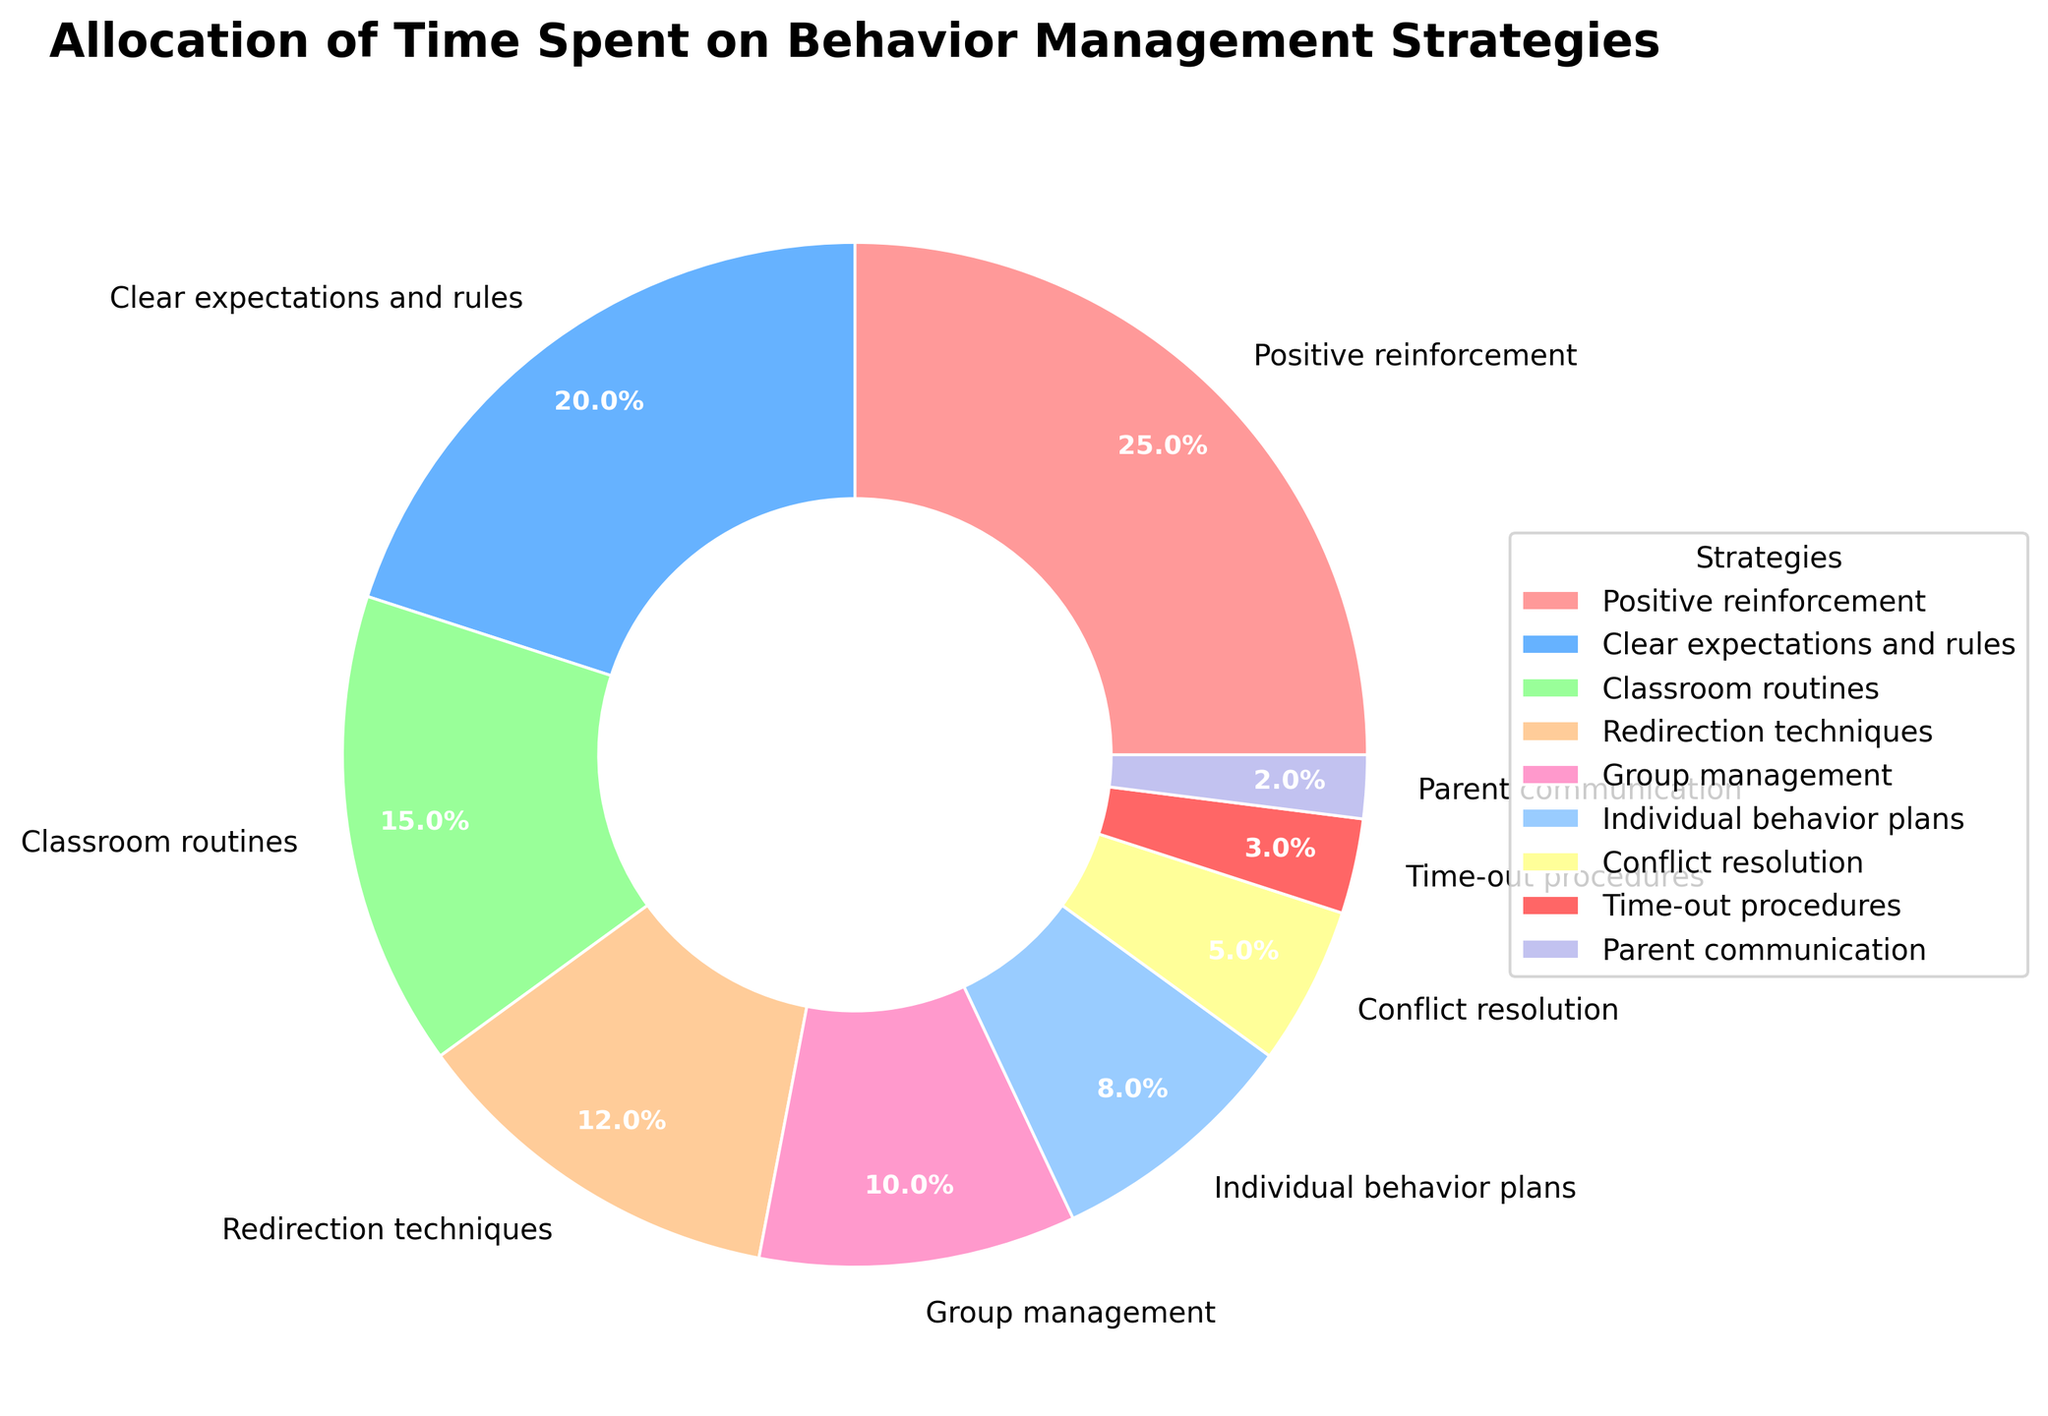Which strategy takes up the largest portion of time? The wedge labeled "Positive reinforcement" is the largest slice of the pie chart.
Answer: Positive reinforcement How much time is spent on Clear expectations and rules compared to Group management? Group management takes 10% of the time, whereas Clear expectations and rules take 20%, which is exactly double.
Answer: Double What is the combined percentage of time spent on Redirection techniques and Individual behavior plans? Redirection techniques take up 12% and Individual behavior plans take 8%. Adding these together gives 12% + 8% = 20%.
Answer: 20% Which color represents Classroom routines on the pie chart? The slice labeled "Classroom routines" is represented by a green color.
Answer: Green How much more time is spent on Positive reinforcement than on Parent communication? Positive reinforcement is 25% and Parent communication is 2%. The difference is 25% - 2% = 23%.
Answer: 23% What percentage of time is allocated to strategies involving individual-focused approaches (Individual behavior plans and Time-out procedures)? Individual behavior plans take 8% and Time-out procedures take 3%. Adding them together gives 8% + 3% = 11%.
Answer: 11% Between Conflict resolution and Redirection techniques, which strategy takes up less time? Conflict resolution takes up 5% and Redirection techniques take up 12%. Therefore, Conflict resolution takes up less time.
Answer: Conflict resolution How does the time spent on Classroom routines compare to the time spent on Group management? Classroom routines take 15% of the time, whereas Group management takes 10%. Classroom routines take more time.
Answer: More time What is the total percentage of time spent on strategies that involve direct interaction with students (Positive reinforcement, Redirection techniques, Group management, and Conflict resolution)? Positive reinforcement: 25%, Redirection techniques: 12%, Group management: 10%, Conflict resolution: 5%. The total is 25% + 12% + 10% + 5% = 52%.
Answer: 52% Which has a smaller percentage: Time-out procedures or Parent communication? Time-out procedures is 3% and Parent communication is 2%. Therefore, Parent communication has a smaller percentage.
Answer: Parent communication 